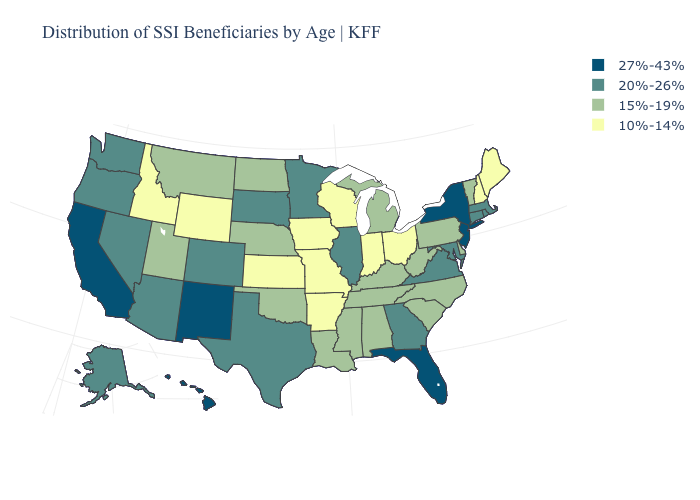Name the states that have a value in the range 15%-19%?
Quick response, please. Alabama, Delaware, Kentucky, Louisiana, Michigan, Mississippi, Montana, Nebraska, North Carolina, North Dakota, Oklahoma, Pennsylvania, South Carolina, Tennessee, Utah, Vermont, West Virginia. What is the value of Maine?
Write a very short answer. 10%-14%. Does Georgia have the lowest value in the USA?
Answer briefly. No. What is the value of Rhode Island?
Answer briefly. 20%-26%. Does Massachusetts have a lower value than New Jersey?
Quick response, please. Yes. Name the states that have a value in the range 20%-26%?
Give a very brief answer. Alaska, Arizona, Colorado, Connecticut, Georgia, Illinois, Maryland, Massachusetts, Minnesota, Nevada, Oregon, Rhode Island, South Dakota, Texas, Virginia, Washington. Does Illinois have the lowest value in the USA?
Short answer required. No. Name the states that have a value in the range 10%-14%?
Keep it brief. Arkansas, Idaho, Indiana, Iowa, Kansas, Maine, Missouri, New Hampshire, Ohio, Wisconsin, Wyoming. Does the first symbol in the legend represent the smallest category?
Give a very brief answer. No. What is the value of Arizona?
Answer briefly. 20%-26%. Name the states that have a value in the range 15%-19%?
Give a very brief answer. Alabama, Delaware, Kentucky, Louisiana, Michigan, Mississippi, Montana, Nebraska, North Carolina, North Dakota, Oklahoma, Pennsylvania, South Carolina, Tennessee, Utah, Vermont, West Virginia. Name the states that have a value in the range 20%-26%?
Answer briefly. Alaska, Arizona, Colorado, Connecticut, Georgia, Illinois, Maryland, Massachusetts, Minnesota, Nevada, Oregon, Rhode Island, South Dakota, Texas, Virginia, Washington. Name the states that have a value in the range 20%-26%?
Write a very short answer. Alaska, Arizona, Colorado, Connecticut, Georgia, Illinois, Maryland, Massachusetts, Minnesota, Nevada, Oregon, Rhode Island, South Dakota, Texas, Virginia, Washington. Does the first symbol in the legend represent the smallest category?
Be succinct. No. What is the highest value in the South ?
Give a very brief answer. 27%-43%. 